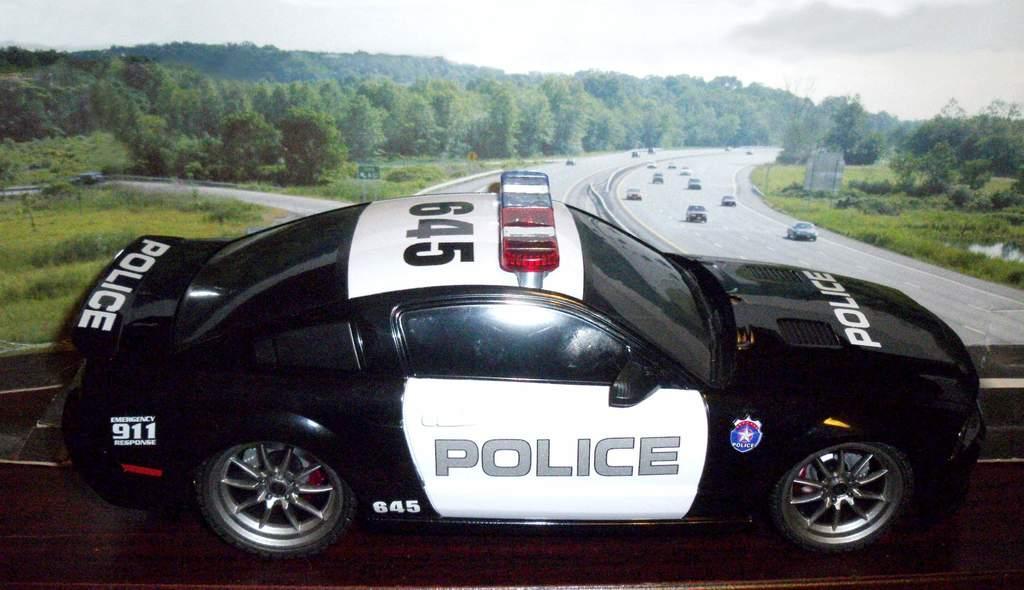Please provide a concise description of this image. In the picture we can see a police car which is black in color on the bridge and on the car we can see a number 645 and siren light on it and behind the car we can see a road with vehicles on it and on the either sides of the road we can see a grass surface with plants and trees and in the background we can see a hill with trees and behind it we can see a sky with clouds. 